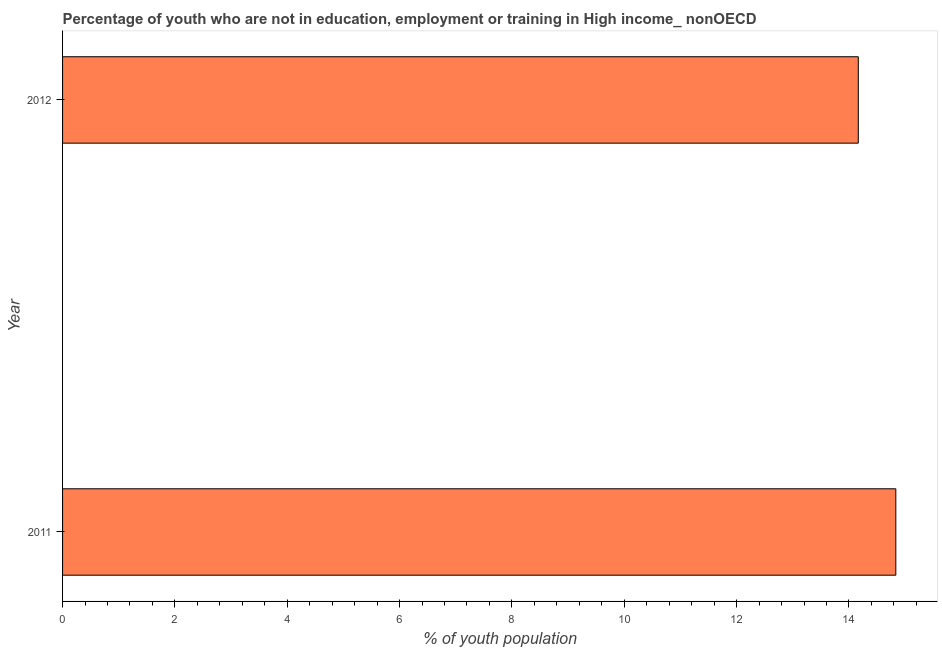Does the graph contain any zero values?
Offer a terse response. No. Does the graph contain grids?
Offer a very short reply. No. What is the title of the graph?
Make the answer very short. Percentage of youth who are not in education, employment or training in High income_ nonOECD. What is the label or title of the X-axis?
Provide a short and direct response. % of youth population. What is the label or title of the Y-axis?
Provide a short and direct response. Year. What is the unemployed youth population in 2012?
Give a very brief answer. 14.17. Across all years, what is the maximum unemployed youth population?
Provide a short and direct response. 14.83. Across all years, what is the minimum unemployed youth population?
Offer a terse response. 14.17. In which year was the unemployed youth population minimum?
Offer a very short reply. 2012. What is the sum of the unemployed youth population?
Provide a short and direct response. 29. What is the difference between the unemployed youth population in 2011 and 2012?
Make the answer very short. 0.67. What is the average unemployed youth population per year?
Offer a very short reply. 14.5. What is the median unemployed youth population?
Your answer should be compact. 14.5. In how many years, is the unemployed youth population greater than 14 %?
Your answer should be very brief. 2. What is the ratio of the unemployed youth population in 2011 to that in 2012?
Offer a terse response. 1.05. Is the unemployed youth population in 2011 less than that in 2012?
Provide a short and direct response. No. How many bars are there?
Your response must be concise. 2. Are all the bars in the graph horizontal?
Your response must be concise. Yes. How many years are there in the graph?
Your answer should be compact. 2. What is the difference between two consecutive major ticks on the X-axis?
Provide a succinct answer. 2. Are the values on the major ticks of X-axis written in scientific E-notation?
Your answer should be very brief. No. What is the % of youth population of 2011?
Give a very brief answer. 14.83. What is the % of youth population of 2012?
Make the answer very short. 14.17. What is the difference between the % of youth population in 2011 and 2012?
Your answer should be compact. 0.67. What is the ratio of the % of youth population in 2011 to that in 2012?
Give a very brief answer. 1.05. 